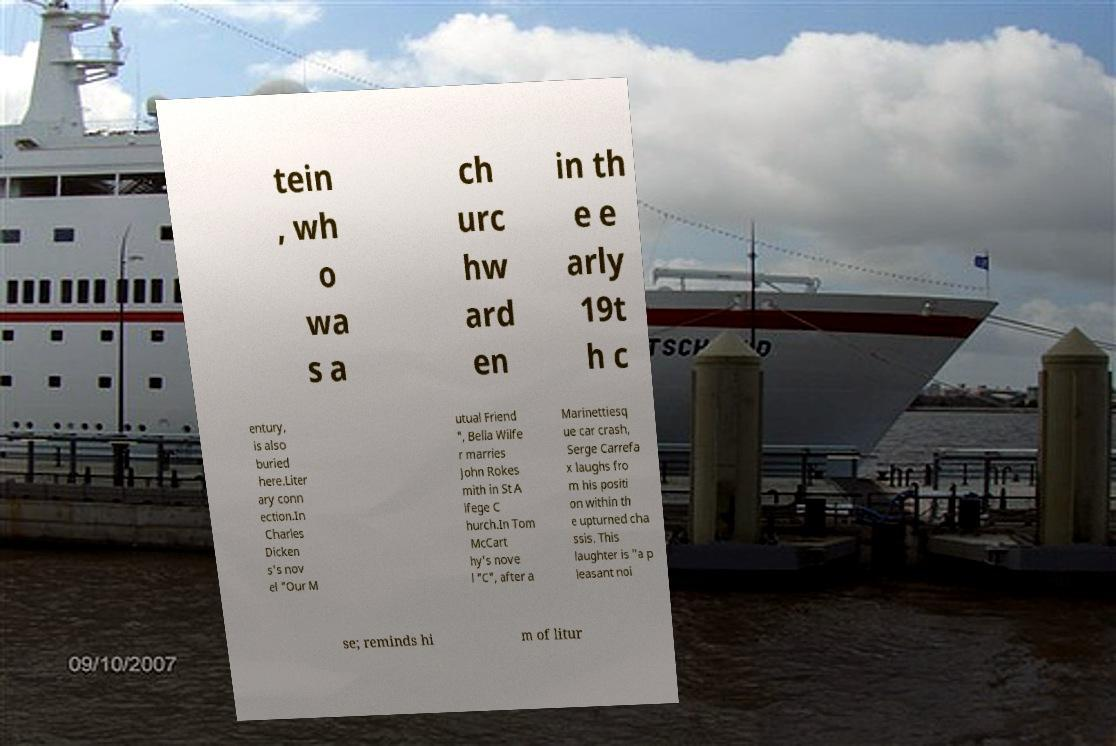Can you read and provide the text displayed in the image?This photo seems to have some interesting text. Can you extract and type it out for me? tein , wh o wa s a ch urc hw ard en in th e e arly 19t h c entury, is also buried here.Liter ary conn ection.In Charles Dicken s's nov el "Our M utual Friend ", Bella Wilfe r marries John Rokes mith in St A lfege C hurch.In Tom McCart hy's nove l "C", after a Marinettiesq ue car crash, Serge Carrefa x laughs fro m his positi on within th e upturned cha ssis. This laughter is "a p leasant noi se; reminds hi m of litur 